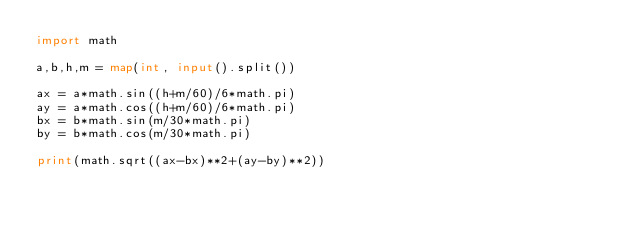Convert code to text. <code><loc_0><loc_0><loc_500><loc_500><_Python_>import math

a,b,h,m = map(int, input().split())

ax = a*math.sin((h+m/60)/6*math.pi)
ay = a*math.cos((h+m/60)/6*math.pi)
bx = b*math.sin(m/30*math.pi)
by = b*math.cos(m/30*math.pi)

print(math.sqrt((ax-bx)**2+(ay-by)**2))</code> 